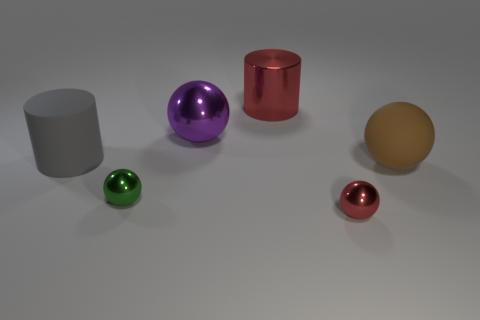Subtract all blue spheres. Subtract all green blocks. How many spheres are left? 4 Add 2 large brown objects. How many objects exist? 8 Subtract all spheres. How many objects are left? 2 Add 4 tiny green balls. How many tiny green balls are left? 5 Add 1 green shiny objects. How many green shiny objects exist? 2 Subtract 0 gray spheres. How many objects are left? 6 Subtract all rubber spheres. Subtract all large matte objects. How many objects are left? 3 